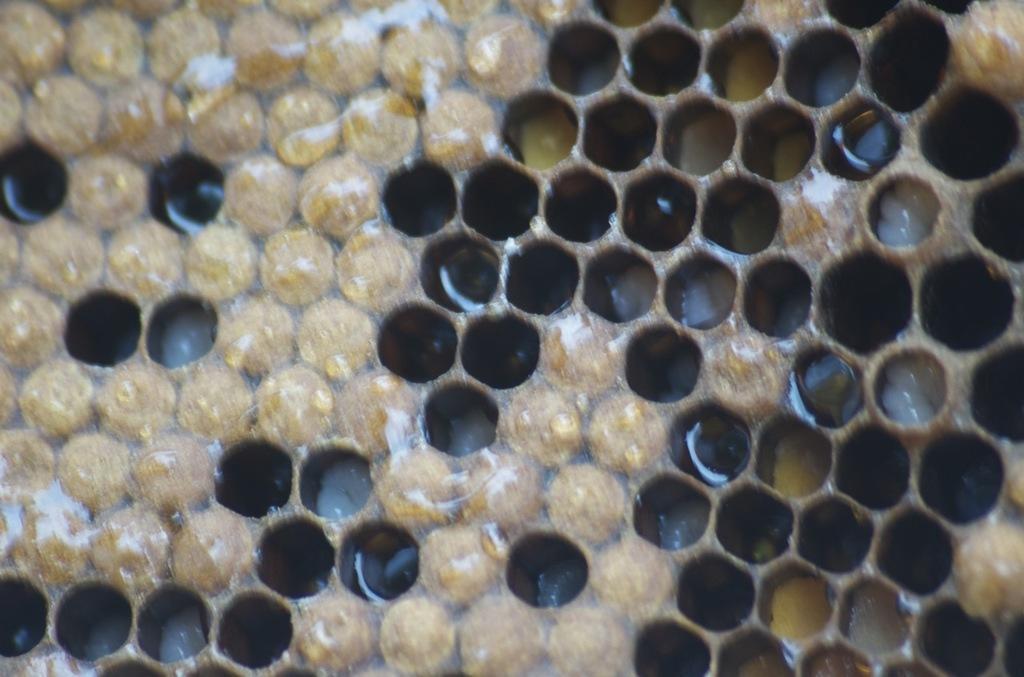How would you summarize this image in a sentence or two? In this image I can see the honeycomb which is in brown and cream color. 